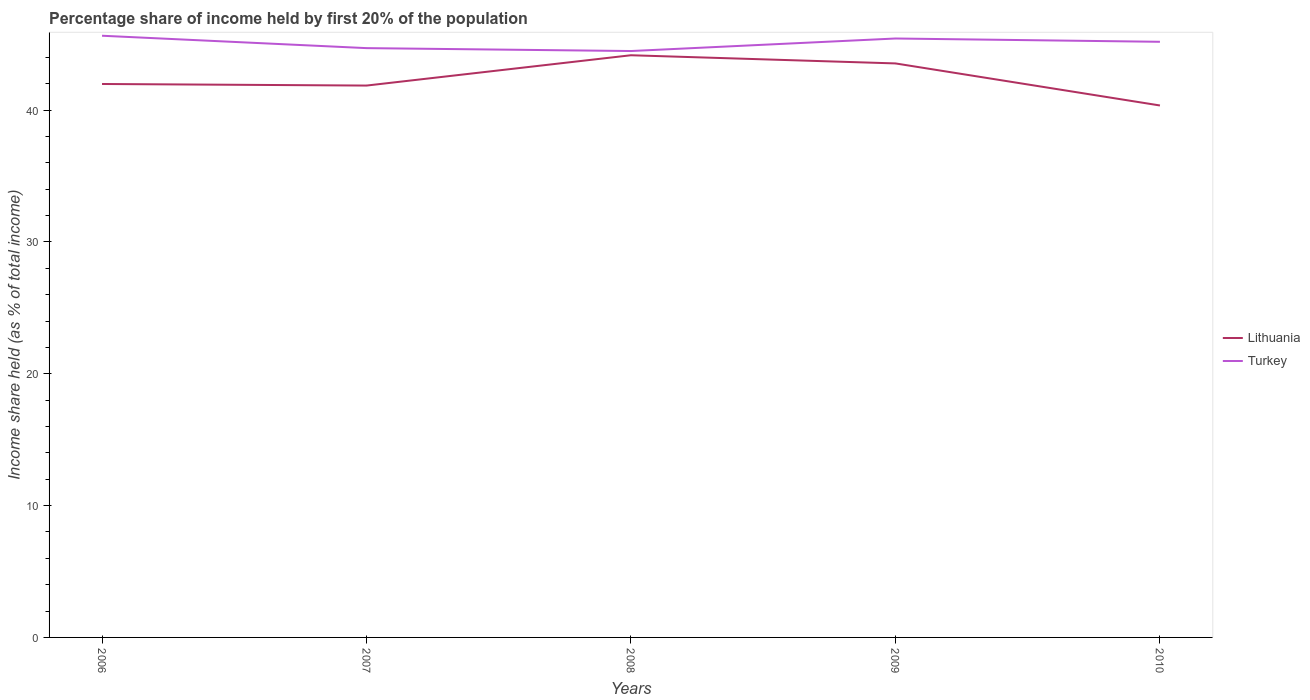Across all years, what is the maximum share of income held by first 20% of the population in Lithuania?
Offer a terse response. 40.35. What is the total share of income held by first 20% of the population in Turkey in the graph?
Ensure brevity in your answer.  1.16. What is the difference between the highest and the second highest share of income held by first 20% of the population in Lithuania?
Your answer should be very brief. 3.81. What is the difference between the highest and the lowest share of income held by first 20% of the population in Lithuania?
Offer a very short reply. 2. Is the share of income held by first 20% of the population in Turkey strictly greater than the share of income held by first 20% of the population in Lithuania over the years?
Your response must be concise. No. How many lines are there?
Your response must be concise. 2. Does the graph contain grids?
Your response must be concise. No. How are the legend labels stacked?
Your answer should be very brief. Vertical. What is the title of the graph?
Keep it short and to the point. Percentage share of income held by first 20% of the population. Does "Mongolia" appear as one of the legend labels in the graph?
Give a very brief answer. No. What is the label or title of the Y-axis?
Your response must be concise. Income share held (as % of total income). What is the Income share held (as % of total income) of Lithuania in 2006?
Your answer should be very brief. 41.98. What is the Income share held (as % of total income) in Turkey in 2006?
Your response must be concise. 45.64. What is the Income share held (as % of total income) of Lithuania in 2007?
Provide a short and direct response. 41.86. What is the Income share held (as % of total income) in Turkey in 2007?
Provide a succinct answer. 44.7. What is the Income share held (as % of total income) in Lithuania in 2008?
Give a very brief answer. 44.16. What is the Income share held (as % of total income) in Turkey in 2008?
Offer a terse response. 44.48. What is the Income share held (as % of total income) of Lithuania in 2009?
Offer a terse response. 43.54. What is the Income share held (as % of total income) in Turkey in 2009?
Make the answer very short. 45.43. What is the Income share held (as % of total income) in Lithuania in 2010?
Give a very brief answer. 40.35. What is the Income share held (as % of total income) of Turkey in 2010?
Offer a very short reply. 45.18. Across all years, what is the maximum Income share held (as % of total income) in Lithuania?
Give a very brief answer. 44.16. Across all years, what is the maximum Income share held (as % of total income) in Turkey?
Ensure brevity in your answer.  45.64. Across all years, what is the minimum Income share held (as % of total income) in Lithuania?
Your answer should be compact. 40.35. Across all years, what is the minimum Income share held (as % of total income) in Turkey?
Your response must be concise. 44.48. What is the total Income share held (as % of total income) in Lithuania in the graph?
Provide a short and direct response. 211.89. What is the total Income share held (as % of total income) of Turkey in the graph?
Provide a short and direct response. 225.43. What is the difference between the Income share held (as % of total income) in Lithuania in 2006 and that in 2007?
Ensure brevity in your answer.  0.12. What is the difference between the Income share held (as % of total income) in Lithuania in 2006 and that in 2008?
Offer a very short reply. -2.18. What is the difference between the Income share held (as % of total income) of Turkey in 2006 and that in 2008?
Keep it short and to the point. 1.16. What is the difference between the Income share held (as % of total income) in Lithuania in 2006 and that in 2009?
Give a very brief answer. -1.56. What is the difference between the Income share held (as % of total income) in Turkey in 2006 and that in 2009?
Provide a short and direct response. 0.21. What is the difference between the Income share held (as % of total income) of Lithuania in 2006 and that in 2010?
Provide a succinct answer. 1.63. What is the difference between the Income share held (as % of total income) of Turkey in 2006 and that in 2010?
Provide a succinct answer. 0.46. What is the difference between the Income share held (as % of total income) of Turkey in 2007 and that in 2008?
Your answer should be compact. 0.22. What is the difference between the Income share held (as % of total income) in Lithuania in 2007 and that in 2009?
Offer a very short reply. -1.68. What is the difference between the Income share held (as % of total income) of Turkey in 2007 and that in 2009?
Ensure brevity in your answer.  -0.73. What is the difference between the Income share held (as % of total income) in Lithuania in 2007 and that in 2010?
Your answer should be very brief. 1.51. What is the difference between the Income share held (as % of total income) of Turkey in 2007 and that in 2010?
Provide a short and direct response. -0.48. What is the difference between the Income share held (as % of total income) in Lithuania in 2008 and that in 2009?
Give a very brief answer. 0.62. What is the difference between the Income share held (as % of total income) in Turkey in 2008 and that in 2009?
Offer a terse response. -0.95. What is the difference between the Income share held (as % of total income) of Lithuania in 2008 and that in 2010?
Offer a terse response. 3.81. What is the difference between the Income share held (as % of total income) in Lithuania in 2009 and that in 2010?
Your answer should be very brief. 3.19. What is the difference between the Income share held (as % of total income) in Turkey in 2009 and that in 2010?
Your answer should be compact. 0.25. What is the difference between the Income share held (as % of total income) in Lithuania in 2006 and the Income share held (as % of total income) in Turkey in 2007?
Give a very brief answer. -2.72. What is the difference between the Income share held (as % of total income) of Lithuania in 2006 and the Income share held (as % of total income) of Turkey in 2008?
Give a very brief answer. -2.5. What is the difference between the Income share held (as % of total income) in Lithuania in 2006 and the Income share held (as % of total income) in Turkey in 2009?
Your response must be concise. -3.45. What is the difference between the Income share held (as % of total income) of Lithuania in 2007 and the Income share held (as % of total income) of Turkey in 2008?
Ensure brevity in your answer.  -2.62. What is the difference between the Income share held (as % of total income) of Lithuania in 2007 and the Income share held (as % of total income) of Turkey in 2009?
Give a very brief answer. -3.57. What is the difference between the Income share held (as % of total income) of Lithuania in 2007 and the Income share held (as % of total income) of Turkey in 2010?
Provide a short and direct response. -3.32. What is the difference between the Income share held (as % of total income) in Lithuania in 2008 and the Income share held (as % of total income) in Turkey in 2009?
Provide a short and direct response. -1.27. What is the difference between the Income share held (as % of total income) of Lithuania in 2008 and the Income share held (as % of total income) of Turkey in 2010?
Your answer should be very brief. -1.02. What is the difference between the Income share held (as % of total income) in Lithuania in 2009 and the Income share held (as % of total income) in Turkey in 2010?
Provide a succinct answer. -1.64. What is the average Income share held (as % of total income) in Lithuania per year?
Your response must be concise. 42.38. What is the average Income share held (as % of total income) of Turkey per year?
Give a very brief answer. 45.09. In the year 2006, what is the difference between the Income share held (as % of total income) of Lithuania and Income share held (as % of total income) of Turkey?
Your answer should be compact. -3.66. In the year 2007, what is the difference between the Income share held (as % of total income) in Lithuania and Income share held (as % of total income) in Turkey?
Offer a very short reply. -2.84. In the year 2008, what is the difference between the Income share held (as % of total income) in Lithuania and Income share held (as % of total income) in Turkey?
Offer a terse response. -0.32. In the year 2009, what is the difference between the Income share held (as % of total income) in Lithuania and Income share held (as % of total income) in Turkey?
Provide a succinct answer. -1.89. In the year 2010, what is the difference between the Income share held (as % of total income) in Lithuania and Income share held (as % of total income) in Turkey?
Provide a succinct answer. -4.83. What is the ratio of the Income share held (as % of total income) in Turkey in 2006 to that in 2007?
Provide a succinct answer. 1.02. What is the ratio of the Income share held (as % of total income) in Lithuania in 2006 to that in 2008?
Offer a very short reply. 0.95. What is the ratio of the Income share held (as % of total income) of Turkey in 2006 to that in 2008?
Give a very brief answer. 1.03. What is the ratio of the Income share held (as % of total income) in Lithuania in 2006 to that in 2009?
Provide a succinct answer. 0.96. What is the ratio of the Income share held (as % of total income) of Lithuania in 2006 to that in 2010?
Give a very brief answer. 1.04. What is the ratio of the Income share held (as % of total income) of Turkey in 2006 to that in 2010?
Your answer should be compact. 1.01. What is the ratio of the Income share held (as % of total income) in Lithuania in 2007 to that in 2008?
Offer a terse response. 0.95. What is the ratio of the Income share held (as % of total income) in Lithuania in 2007 to that in 2009?
Give a very brief answer. 0.96. What is the ratio of the Income share held (as % of total income) of Turkey in 2007 to that in 2009?
Make the answer very short. 0.98. What is the ratio of the Income share held (as % of total income) in Lithuania in 2007 to that in 2010?
Offer a very short reply. 1.04. What is the ratio of the Income share held (as % of total income) in Lithuania in 2008 to that in 2009?
Provide a succinct answer. 1.01. What is the ratio of the Income share held (as % of total income) of Turkey in 2008 to that in 2009?
Offer a terse response. 0.98. What is the ratio of the Income share held (as % of total income) in Lithuania in 2008 to that in 2010?
Make the answer very short. 1.09. What is the ratio of the Income share held (as % of total income) of Turkey in 2008 to that in 2010?
Provide a short and direct response. 0.98. What is the ratio of the Income share held (as % of total income) of Lithuania in 2009 to that in 2010?
Your answer should be very brief. 1.08. What is the ratio of the Income share held (as % of total income) of Turkey in 2009 to that in 2010?
Keep it short and to the point. 1.01. What is the difference between the highest and the second highest Income share held (as % of total income) of Lithuania?
Your answer should be compact. 0.62. What is the difference between the highest and the second highest Income share held (as % of total income) of Turkey?
Provide a succinct answer. 0.21. What is the difference between the highest and the lowest Income share held (as % of total income) in Lithuania?
Offer a very short reply. 3.81. What is the difference between the highest and the lowest Income share held (as % of total income) of Turkey?
Offer a very short reply. 1.16. 